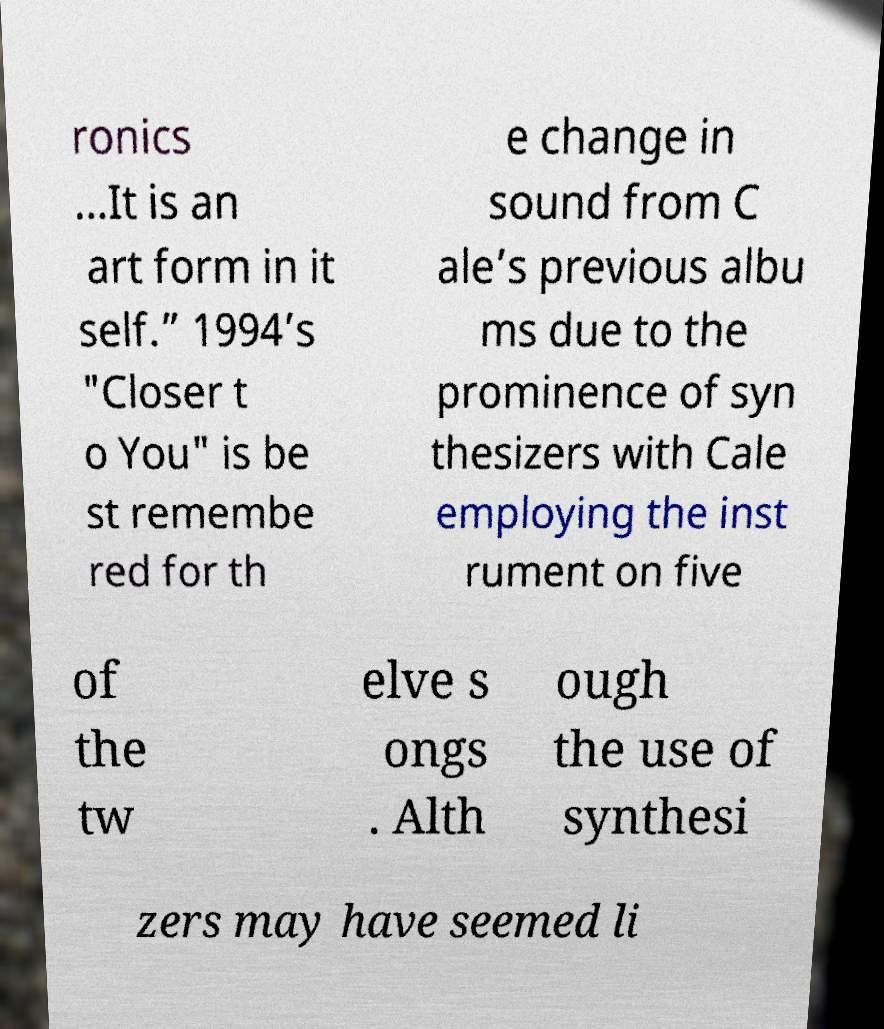Can you accurately transcribe the text from the provided image for me? ronics …It is an art form in it self.” 1994’s "Closer t o You" is be st remembe red for th e change in sound from C ale’s previous albu ms due to the prominence of syn thesizers with Cale employing the inst rument on five of the tw elve s ongs . Alth ough the use of synthesi zers may have seemed li 